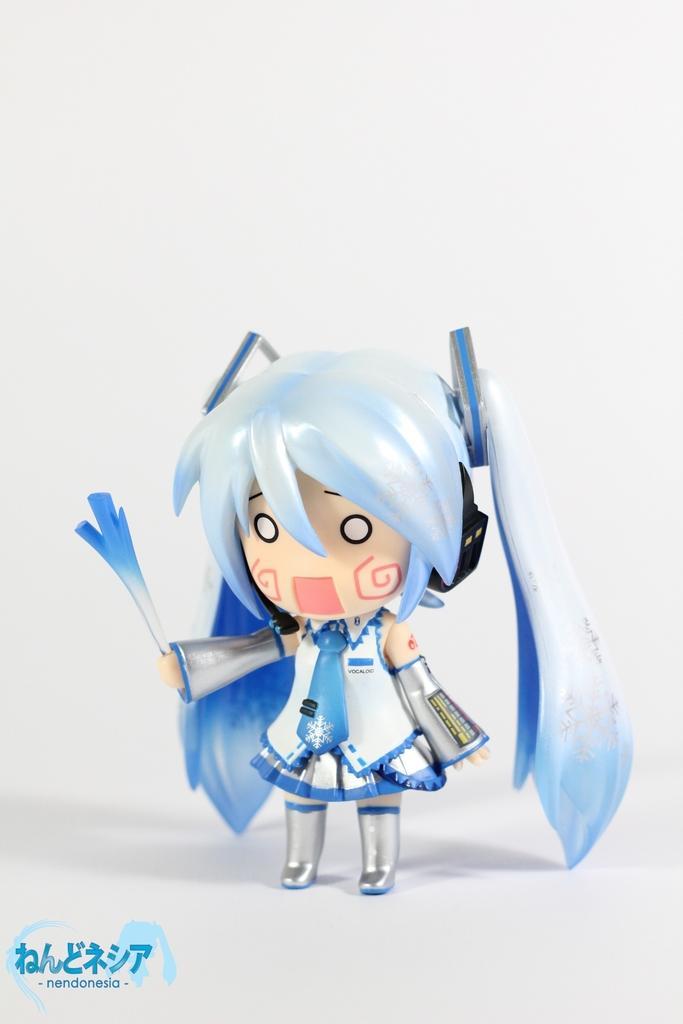Please provide a concise description of this image. In this image there is a toy of a girl. In the bottom left there is text on the image. The background is white. 